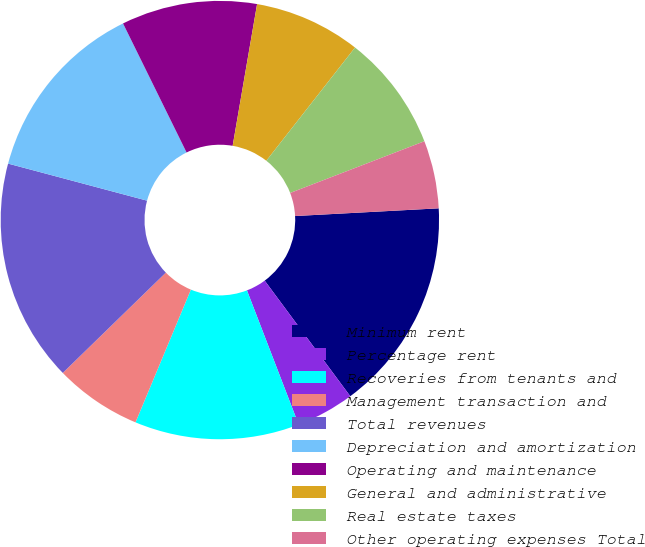<chart> <loc_0><loc_0><loc_500><loc_500><pie_chart><fcel>Minimum rent<fcel>Percentage rent<fcel>Recoveries from tenants and<fcel>Management transaction and<fcel>Total revenues<fcel>Depreciation and amortization<fcel>Operating and maintenance<fcel>General and administrative<fcel>Real estate taxes<fcel>Other operating expenses Total<nl><fcel>15.71%<fcel>4.29%<fcel>12.14%<fcel>6.43%<fcel>16.43%<fcel>13.57%<fcel>10.0%<fcel>7.86%<fcel>8.57%<fcel>5.0%<nl></chart> 